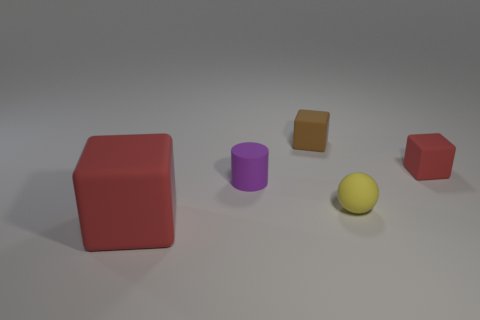What shape is the purple matte object that is on the left side of the red thing that is to the right of the rubber thing that is left of the purple matte cylinder?
Provide a short and direct response. Cylinder. How many cylinders are either purple matte things or yellow matte objects?
Your response must be concise. 1. There is a brown thing that is to the right of the cylinder; are there any small purple things behind it?
Your answer should be compact. No. Is there any other thing that is the same material as the big block?
Your answer should be very brief. Yes. There is a purple object; does it have the same shape as the red thing behind the tiny yellow rubber ball?
Keep it short and to the point. No. What number of other objects are there of the same size as the purple rubber cylinder?
Offer a terse response. 3. What number of green things are big matte blocks or rubber objects?
Your answer should be very brief. 0. How many red matte things are to the right of the small brown object and to the left of the tiny purple thing?
Your response must be concise. 0. The red cube that is behind the cylinder that is behind the red rubber block on the left side of the purple matte object is made of what material?
Offer a terse response. Rubber. What number of cylinders have the same material as the yellow object?
Give a very brief answer. 1. 